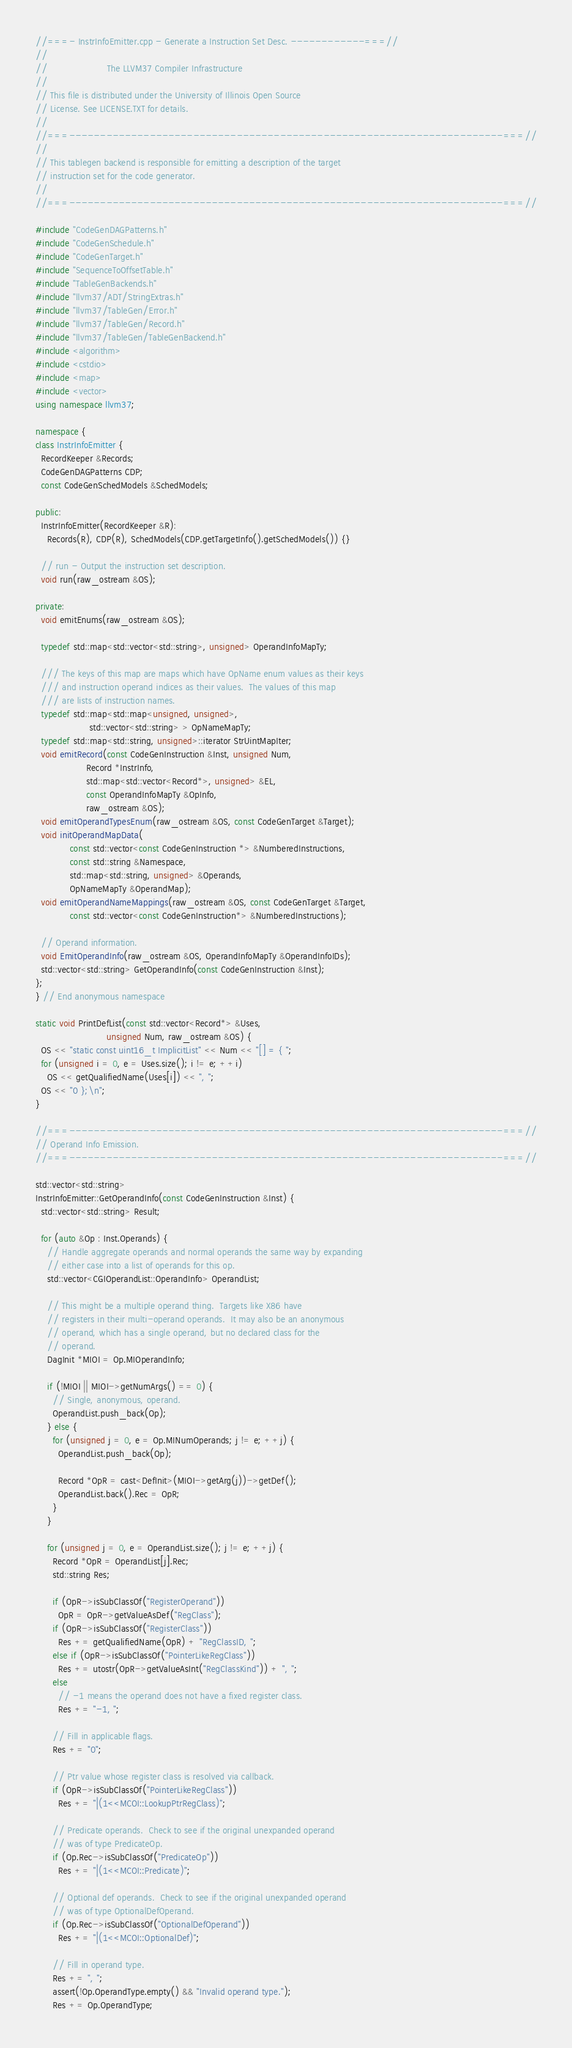Convert code to text. <code><loc_0><loc_0><loc_500><loc_500><_C++_>//===- InstrInfoEmitter.cpp - Generate a Instruction Set Desc. ------------===//
//
//                     The LLVM37 Compiler Infrastructure
//
// This file is distributed under the University of Illinois Open Source
// License. See LICENSE.TXT for details.
//
//===----------------------------------------------------------------------===//
//
// This tablegen backend is responsible for emitting a description of the target
// instruction set for the code generator.
//
//===----------------------------------------------------------------------===//

#include "CodeGenDAGPatterns.h"
#include "CodeGenSchedule.h"
#include "CodeGenTarget.h"
#include "SequenceToOffsetTable.h"
#include "TableGenBackends.h"
#include "llvm37/ADT/StringExtras.h"
#include "llvm37/TableGen/Error.h"
#include "llvm37/TableGen/Record.h"
#include "llvm37/TableGen/TableGenBackend.h"
#include <algorithm>
#include <cstdio>
#include <map>
#include <vector>
using namespace llvm37;

namespace {
class InstrInfoEmitter {
  RecordKeeper &Records;
  CodeGenDAGPatterns CDP;
  const CodeGenSchedModels &SchedModels;

public:
  InstrInfoEmitter(RecordKeeper &R):
    Records(R), CDP(R), SchedModels(CDP.getTargetInfo().getSchedModels()) {}

  // run - Output the instruction set description.
  void run(raw_ostream &OS);

private:
  void emitEnums(raw_ostream &OS);

  typedef std::map<std::vector<std::string>, unsigned> OperandInfoMapTy;

  /// The keys of this map are maps which have OpName enum values as their keys
  /// and instruction operand indices as their values.  The values of this map
  /// are lists of instruction names.
  typedef std::map<std::map<unsigned, unsigned>,
                   std::vector<std::string> > OpNameMapTy;
  typedef std::map<std::string, unsigned>::iterator StrUintMapIter;
  void emitRecord(const CodeGenInstruction &Inst, unsigned Num,
                  Record *InstrInfo,
                  std::map<std::vector<Record*>, unsigned> &EL,
                  const OperandInfoMapTy &OpInfo,
                  raw_ostream &OS);
  void emitOperandTypesEnum(raw_ostream &OS, const CodeGenTarget &Target);
  void initOperandMapData(
            const std::vector<const CodeGenInstruction *> &NumberedInstructions,
            const std::string &Namespace,
            std::map<std::string, unsigned> &Operands,
            OpNameMapTy &OperandMap);
  void emitOperandNameMappings(raw_ostream &OS, const CodeGenTarget &Target,
            const std::vector<const CodeGenInstruction*> &NumberedInstructions);

  // Operand information.
  void EmitOperandInfo(raw_ostream &OS, OperandInfoMapTy &OperandInfoIDs);
  std::vector<std::string> GetOperandInfo(const CodeGenInstruction &Inst);
};
} // End anonymous namespace

static void PrintDefList(const std::vector<Record*> &Uses,
                         unsigned Num, raw_ostream &OS) {
  OS << "static const uint16_t ImplicitList" << Num << "[] = { ";
  for (unsigned i = 0, e = Uses.size(); i != e; ++i)
    OS << getQualifiedName(Uses[i]) << ", ";
  OS << "0 };\n";
}

//===----------------------------------------------------------------------===//
// Operand Info Emission.
//===----------------------------------------------------------------------===//

std::vector<std::string>
InstrInfoEmitter::GetOperandInfo(const CodeGenInstruction &Inst) {
  std::vector<std::string> Result;

  for (auto &Op : Inst.Operands) {
    // Handle aggregate operands and normal operands the same way by expanding
    // either case into a list of operands for this op.
    std::vector<CGIOperandList::OperandInfo> OperandList;

    // This might be a multiple operand thing.  Targets like X86 have
    // registers in their multi-operand operands.  It may also be an anonymous
    // operand, which has a single operand, but no declared class for the
    // operand.
    DagInit *MIOI = Op.MIOperandInfo;

    if (!MIOI || MIOI->getNumArgs() == 0) {
      // Single, anonymous, operand.
      OperandList.push_back(Op);
    } else {
      for (unsigned j = 0, e = Op.MINumOperands; j != e; ++j) {
        OperandList.push_back(Op);

        Record *OpR = cast<DefInit>(MIOI->getArg(j))->getDef();
        OperandList.back().Rec = OpR;
      }
    }

    for (unsigned j = 0, e = OperandList.size(); j != e; ++j) {
      Record *OpR = OperandList[j].Rec;
      std::string Res;

      if (OpR->isSubClassOf("RegisterOperand"))
        OpR = OpR->getValueAsDef("RegClass");
      if (OpR->isSubClassOf("RegisterClass"))
        Res += getQualifiedName(OpR) + "RegClassID, ";
      else if (OpR->isSubClassOf("PointerLikeRegClass"))
        Res += utostr(OpR->getValueAsInt("RegClassKind")) + ", ";
      else
        // -1 means the operand does not have a fixed register class.
        Res += "-1, ";

      // Fill in applicable flags.
      Res += "0";

      // Ptr value whose register class is resolved via callback.
      if (OpR->isSubClassOf("PointerLikeRegClass"))
        Res += "|(1<<MCOI::LookupPtrRegClass)";

      // Predicate operands.  Check to see if the original unexpanded operand
      // was of type PredicateOp.
      if (Op.Rec->isSubClassOf("PredicateOp"))
        Res += "|(1<<MCOI::Predicate)";

      // Optional def operands.  Check to see if the original unexpanded operand
      // was of type OptionalDefOperand.
      if (Op.Rec->isSubClassOf("OptionalDefOperand"))
        Res += "|(1<<MCOI::OptionalDef)";

      // Fill in operand type.
      Res += ", ";
      assert(!Op.OperandType.empty() && "Invalid operand type.");
      Res += Op.OperandType;
</code> 